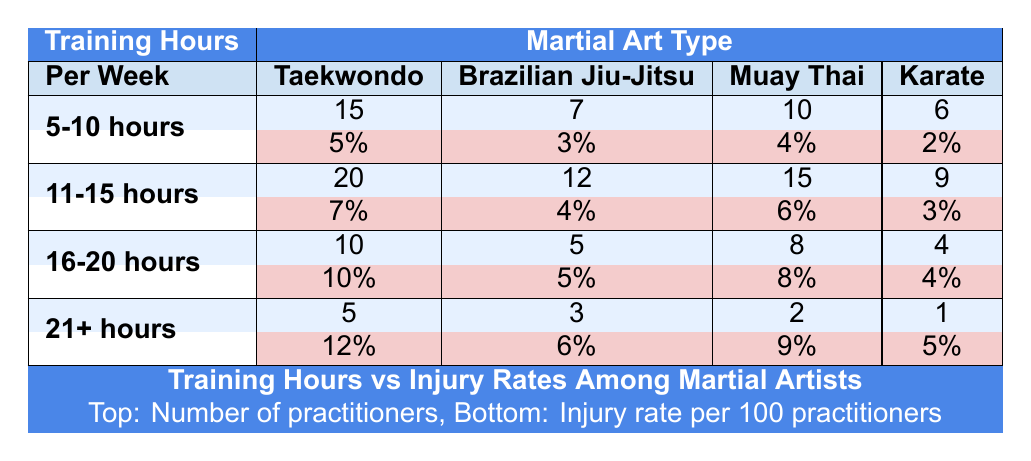What is the injury rate for Taekwondo practitioners who train 5-10 hours per week? The table indicates that the injury rate for Taekwondo practitioners in the 5-10 hours category is 5 percent.
Answer: 5% Which martial art type has the highest number of practitioners training 11-15 hours per week? According to the table, Taekwondo has the highest number of practitioners (20) in the 11-15 hours category.
Answer: Taekwondo What is the total number of practitioners from all martial arts who train 21+ hours per week? Summing the number of practitioners across all martial arts in the 21+ hours category gives us 5 + 3 + 2 + 1 = 11 practitioners.
Answer: 11 Is the injury rate for Brazilian Jiu-Jitsu practitioners lower when training 5-10 hours compared to 16-20 hours? The injury rate for Brazilian Jiu-Jitsu practitioners training 5-10 hours is 3 percent, while for those training 16-20 hours it is 5 percent, making the statement true.
Answer: Yes How much higher is the injury rate for Muay Thai practitioners training 21+ hours compared to those training 11-15 hours? The injury rate for Muay Thai practitioners training 21+ hours is 9 percent, and for those in the 11-15 hours category, it’s 6 percent. The difference is 9 - 6 = 3 percent.
Answer: 3% 